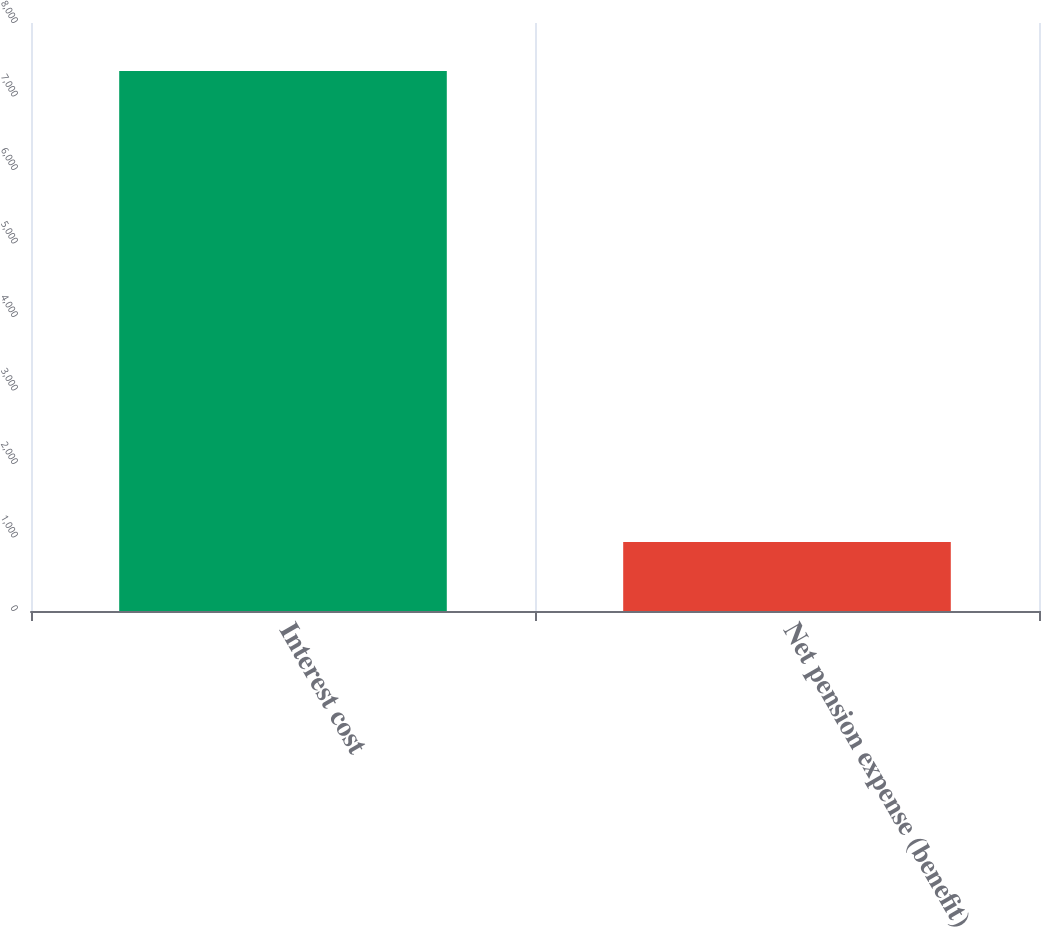<chart> <loc_0><loc_0><loc_500><loc_500><bar_chart><fcel>Interest cost<fcel>Net pension expense (benefit)<nl><fcel>7348<fcel>939<nl></chart> 